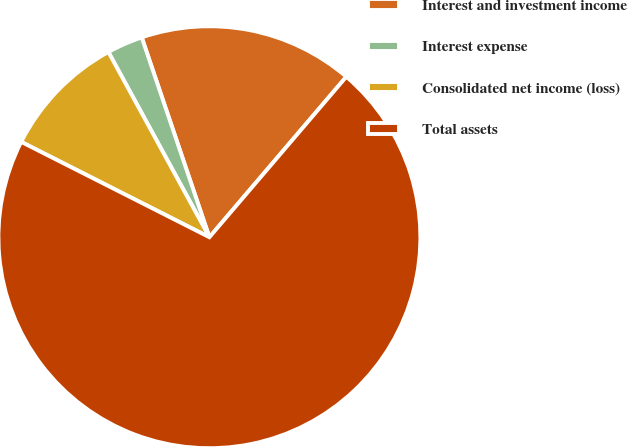<chart> <loc_0><loc_0><loc_500><loc_500><pie_chart><fcel>Interest and investment income<fcel>Interest expense<fcel>Consolidated net income (loss)<fcel>Total assets<nl><fcel>16.44%<fcel>2.75%<fcel>9.59%<fcel>71.22%<nl></chart> 